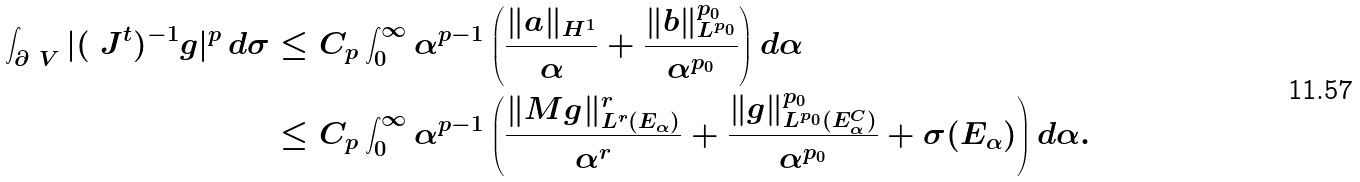<formula> <loc_0><loc_0><loc_500><loc_500>\int _ { \partial \ V } | ( \ J ^ { t } ) ^ { - 1 } g | ^ { p } \, d \sigma & \leq C _ { p } \int _ { 0 } ^ { \infty } \alpha ^ { p - 1 } \left ( \frac { \| a \| _ { H ^ { 1 } } } { \alpha } + \frac { \| b \| _ { L ^ { p _ { 0 } } } ^ { p _ { 0 } } } { \alpha ^ { p _ { 0 } } } \right ) d \alpha \\ & \leq C _ { p } \int _ { 0 } ^ { \infty } \alpha ^ { p - 1 } \left ( \frac { \| M g \| _ { L ^ { r } ( E _ { \alpha } ) } ^ { r } } { \alpha ^ { r } } + \frac { \| g \| _ { L ^ { p _ { 0 } } ( E _ { \alpha } ^ { C } ) } ^ { p _ { 0 } } } { \alpha ^ { p _ { 0 } } } + \sigma ( E _ { \alpha } ) \right ) d \alpha .</formula> 